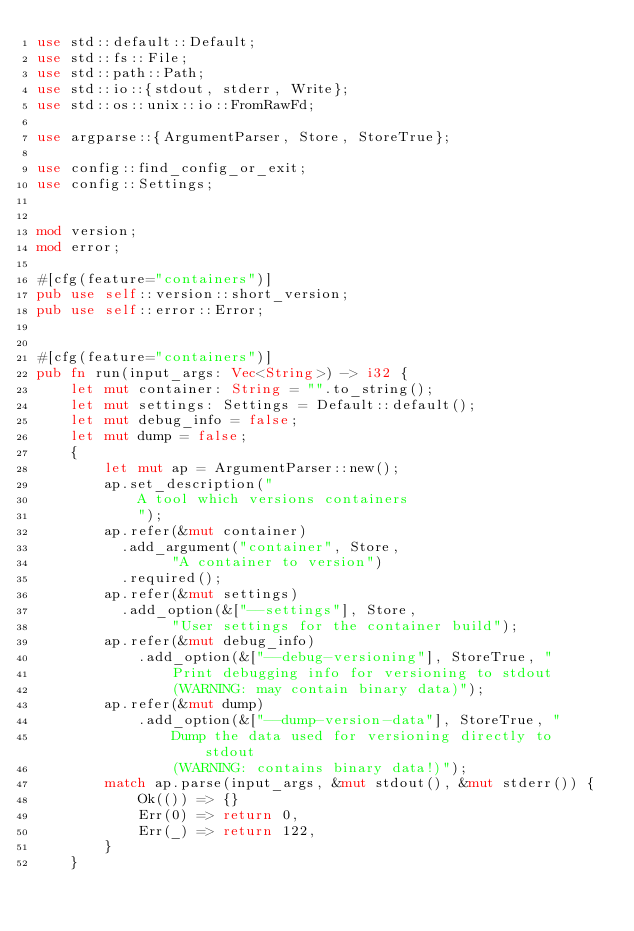Convert code to text. <code><loc_0><loc_0><loc_500><loc_500><_Rust_>use std::default::Default;
use std::fs::File;
use std::path::Path;
use std::io::{stdout, stderr, Write};
use std::os::unix::io::FromRawFd;

use argparse::{ArgumentParser, Store, StoreTrue};

use config::find_config_or_exit;
use config::Settings;


mod version;
mod error;

#[cfg(feature="containers")]
pub use self::version::short_version;
pub use self::error::Error;


#[cfg(feature="containers")]
pub fn run(input_args: Vec<String>) -> i32 {
    let mut container: String = "".to_string();
    let mut settings: Settings = Default::default();
    let mut debug_info = false;
    let mut dump = false;
    {
        let mut ap = ArgumentParser::new();
        ap.set_description("
            A tool which versions containers
            ");
        ap.refer(&mut container)
          .add_argument("container", Store,
                "A container to version")
          .required();
        ap.refer(&mut settings)
          .add_option(&["--settings"], Store,
                "User settings for the container build");
        ap.refer(&mut debug_info)
            .add_option(&["--debug-versioning"], StoreTrue, "
                Print debugging info for versioning to stdout
                (WARNING: may contain binary data)");
        ap.refer(&mut dump)
            .add_option(&["--dump-version-data"], StoreTrue, "
                Dump the data used for versioning directly to stdout
                (WARNING: contains binary data!)");
        match ap.parse(input_args, &mut stdout(), &mut stderr()) {
            Ok(()) => {}
            Err(0) => return 0,
            Err(_) => return 122,
        }
    }
</code> 